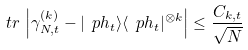<formula> <loc_0><loc_0><loc_500><loc_500>\ t r \, \left | \gamma ^ { ( k ) } _ { N , t } - | \ p h _ { t } \rangle \langle \ p h _ { t } | ^ { \otimes k } \right | \leq \frac { C _ { k , t } } { \sqrt { N } }</formula> 